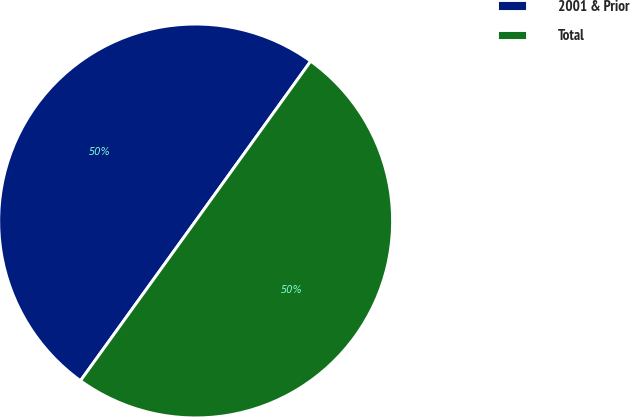Convert chart. <chart><loc_0><loc_0><loc_500><loc_500><pie_chart><fcel>2001 & Prior<fcel>Total<nl><fcel>49.99%<fcel>50.01%<nl></chart> 